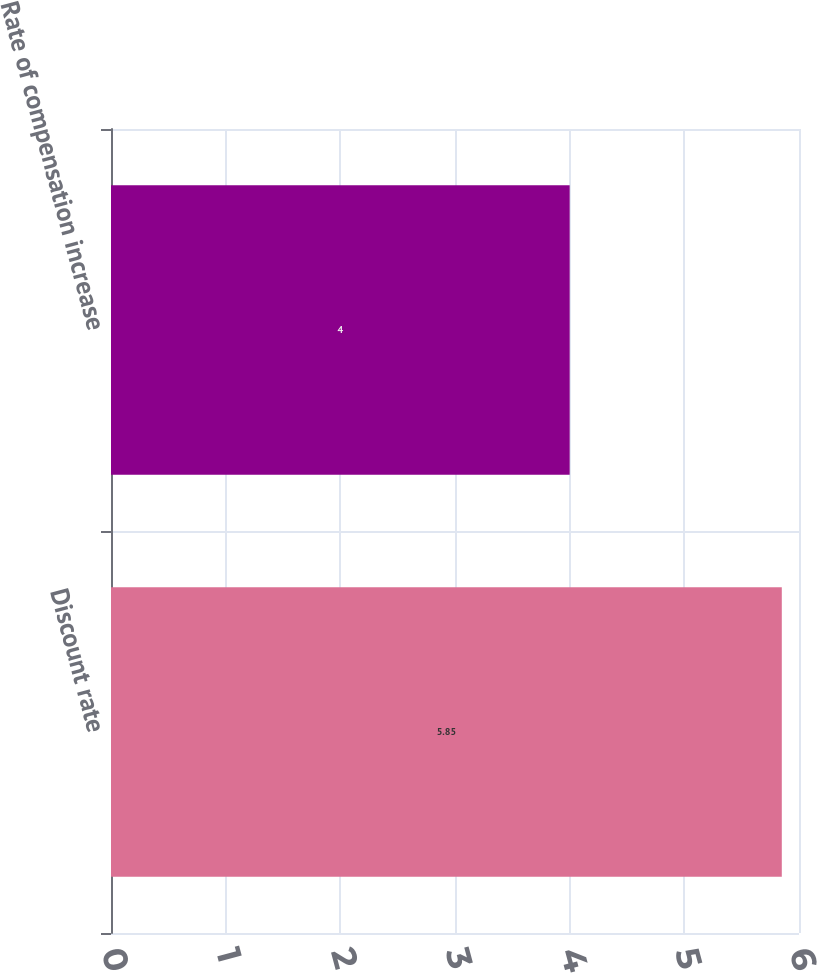<chart> <loc_0><loc_0><loc_500><loc_500><bar_chart><fcel>Discount rate<fcel>Rate of compensation increase<nl><fcel>5.85<fcel>4<nl></chart> 